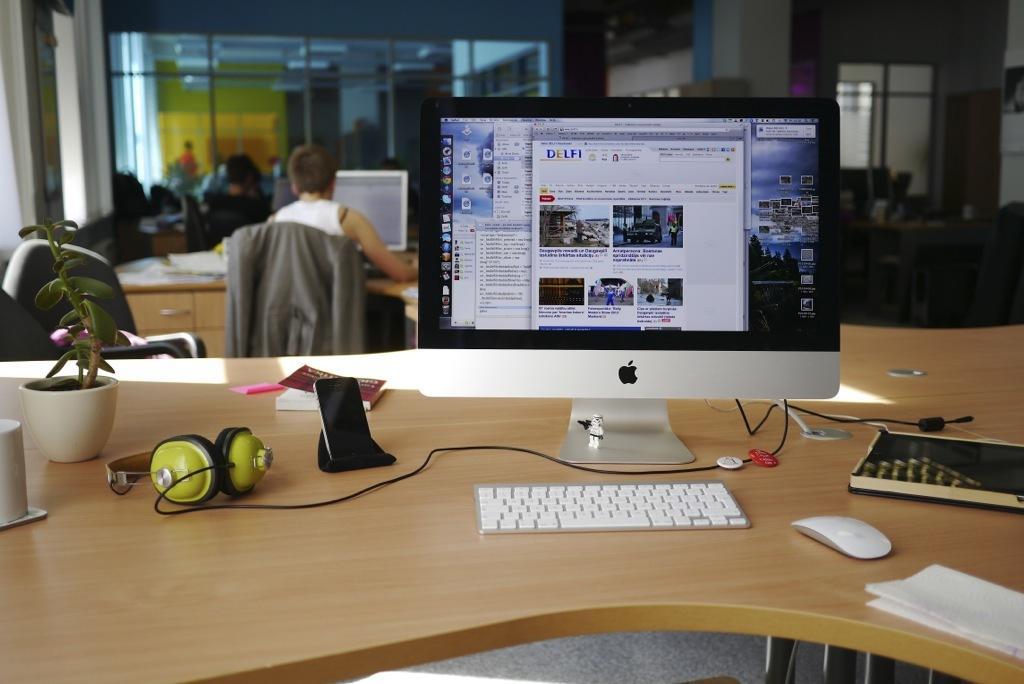Describe this image in one or two sentences. This is a wooden table where a computer with key board, a mouse,a mobile phone, a headset and a clay pot are kept on it. In the background we can see a man sitting on a chair and he is working on a computer. 